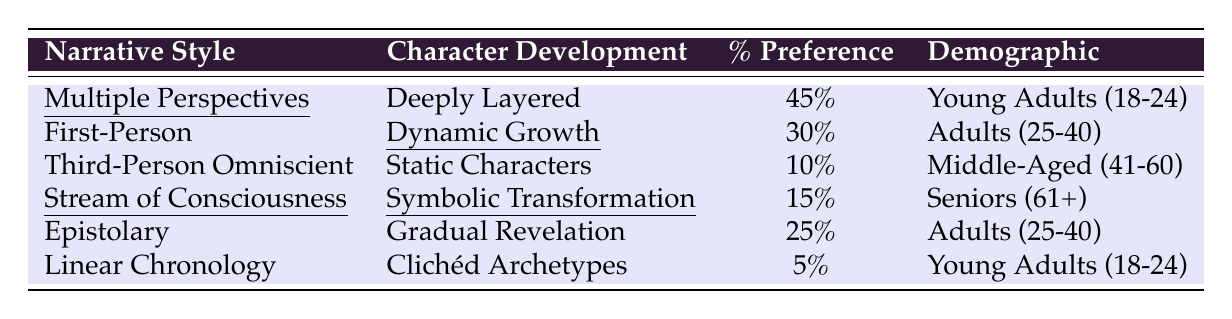What is the percentage preference for "Multiple Perspectives"? The table shows that the percentage preference for "Multiple Perspectives" is recorded as 45%.
Answer: 45% Which character development style has the highest preference among young adults? Looking at the data under the demographic "Young Adults (18-24)", "Deeply Layered" character development corresponds to "Multiple Perspectives" with a preference of 45%, which is the highest in that demographic.
Answer: Deeply Layered What is the total percentage preference for character development styles associated with adults aged 25-40? There are two character development styles for this demographic: "Dynamic Growth" with 30% and "Gradual Revelation" with 25%. Adding these gives 30% + 25% = 55%.
Answer: 55% Is there a character development style that is preferred more than 30% among seniors? The table shows that "Symbolic Transformation" has a preference of 15% among seniors, which is not more than 30%. Thus, no character development style has a preference above 30% for that demographic.
Answer: No What percentage of young adults prefer the "Linear Chronology" narrative style? According to the table, the percentage preference for "Linear Chronology" is noted as 5% for young adults.
Answer: 5% Which narrative style has the lowest preference overall? Reviewing the percentages, "Linear Chronology" has the lowest recorded preference at 5%.
Answer: Linear Chronology What is the average percentage preference for narrative styles among middle-aged respondents? The only narrative style listed for middle-aged respondents (41-60) is "Third-Person Omniscient" with a 10% preference. Therefore, the average is also 10%.
Answer: 10% Which narrative style shows a preference for symbolic transformation among seniors? The table indicates that the narrative style associated with "Symbolic Transformation" is "Stream of Consciousness," which is the only one mentioned for seniors.
Answer: Stream of Consciousness How many different character development styles are listed for adults aged 25-40? The table lists two character development styles for adults aged 25-40: "Dynamic Growth" and "Gradual Revelation." Therefore, there are two.
Answer: 2 What can be inferred about the relationship between narrative styles that feature multiple perspectives and character development? "Multiple Perspectives" correlates with "Deeply Layered" character development and has the highest preference at 45%. It suggests readers appreciate complex character growth in narrative styles that allow for varied viewpoints.
Answer: Complex character growth is preferred 